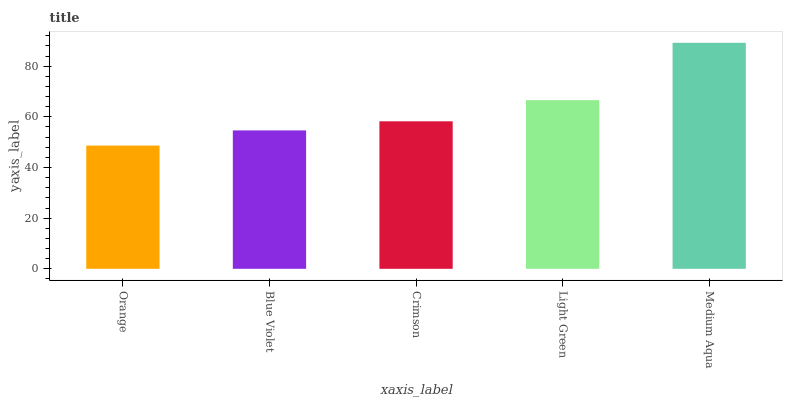Is Orange the minimum?
Answer yes or no. Yes. Is Medium Aqua the maximum?
Answer yes or no. Yes. Is Blue Violet the minimum?
Answer yes or no. No. Is Blue Violet the maximum?
Answer yes or no. No. Is Blue Violet greater than Orange?
Answer yes or no. Yes. Is Orange less than Blue Violet?
Answer yes or no. Yes. Is Orange greater than Blue Violet?
Answer yes or no. No. Is Blue Violet less than Orange?
Answer yes or no. No. Is Crimson the high median?
Answer yes or no. Yes. Is Crimson the low median?
Answer yes or no. Yes. Is Medium Aqua the high median?
Answer yes or no. No. Is Light Green the low median?
Answer yes or no. No. 